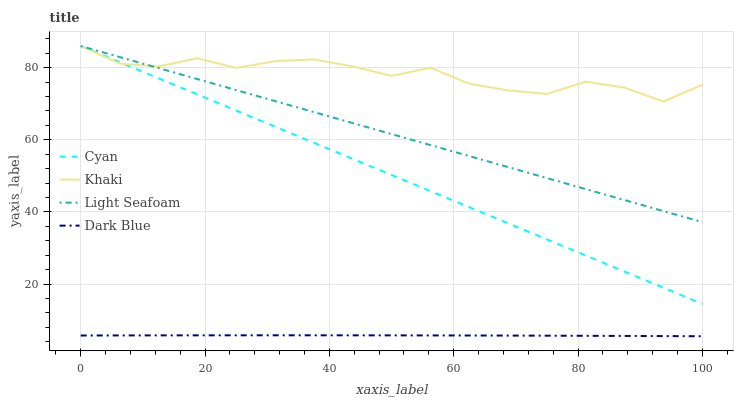Does Dark Blue have the minimum area under the curve?
Answer yes or no. Yes. Does Khaki have the maximum area under the curve?
Answer yes or no. Yes. Does Light Seafoam have the minimum area under the curve?
Answer yes or no. No. Does Light Seafoam have the maximum area under the curve?
Answer yes or no. No. Is Cyan the smoothest?
Answer yes or no. Yes. Is Khaki the roughest?
Answer yes or no. Yes. Is Light Seafoam the smoothest?
Answer yes or no. No. Is Light Seafoam the roughest?
Answer yes or no. No. Does Dark Blue have the lowest value?
Answer yes or no. Yes. Does Light Seafoam have the lowest value?
Answer yes or no. No. Does Light Seafoam have the highest value?
Answer yes or no. Yes. Does Dark Blue have the highest value?
Answer yes or no. No. Is Dark Blue less than Khaki?
Answer yes or no. Yes. Is Light Seafoam greater than Dark Blue?
Answer yes or no. Yes. Does Khaki intersect Cyan?
Answer yes or no. Yes. Is Khaki less than Cyan?
Answer yes or no. No. Is Khaki greater than Cyan?
Answer yes or no. No. Does Dark Blue intersect Khaki?
Answer yes or no. No. 